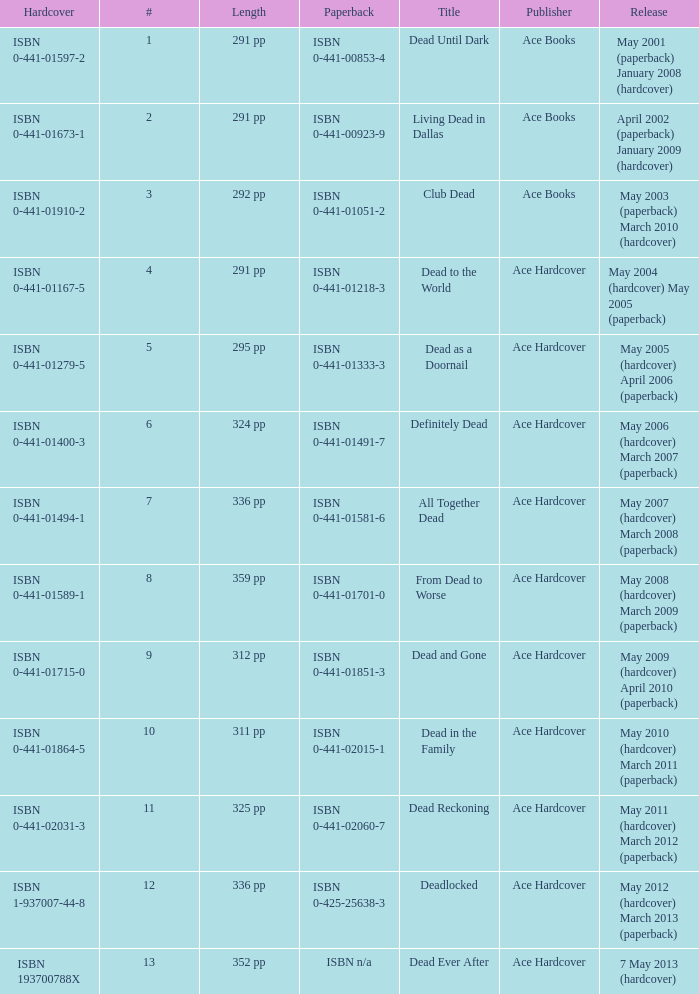Isbn 0-441-01400-3 is book number? 6.0. 